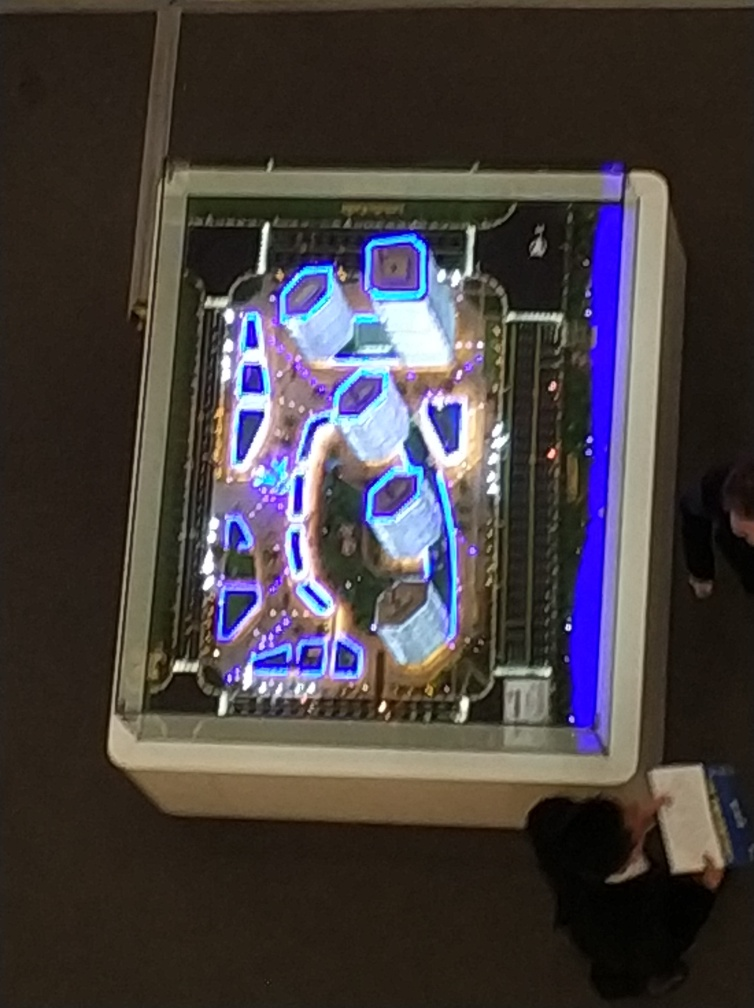Could you guess the purpose of this place? While specifics are hard to ascertain without additional context, the layout and lighting suggest it could be a leisure or shopping area designed for public gatherings and events, highlighted by its striking aesthetic. 